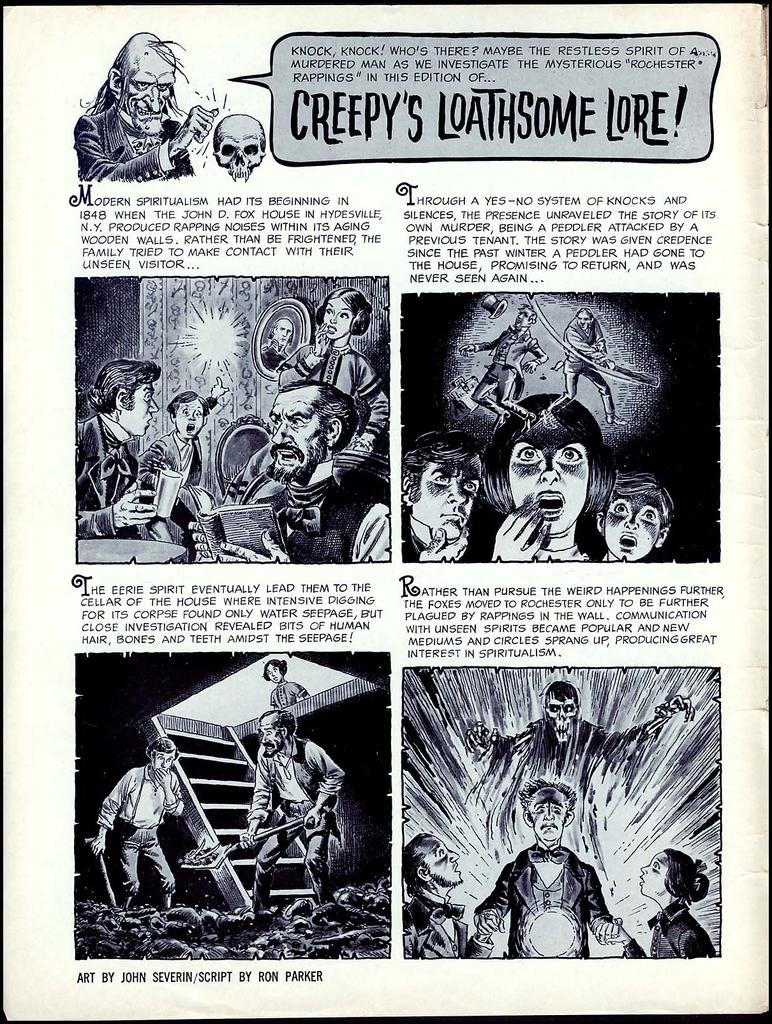What is the color scheme of the image? The image is black and white. What can be seen in the pictures within the image? There are pictures of people in the image. What else is present in the image besides the pictures of people? There is text printed on the image. How many locks can be seen in the image? There are no locks present in the image. What type of shoes are the people wearing in the image? There is no information about the people's shoes in the image, as it is black and white and focuses on the pictures of people and the text. 